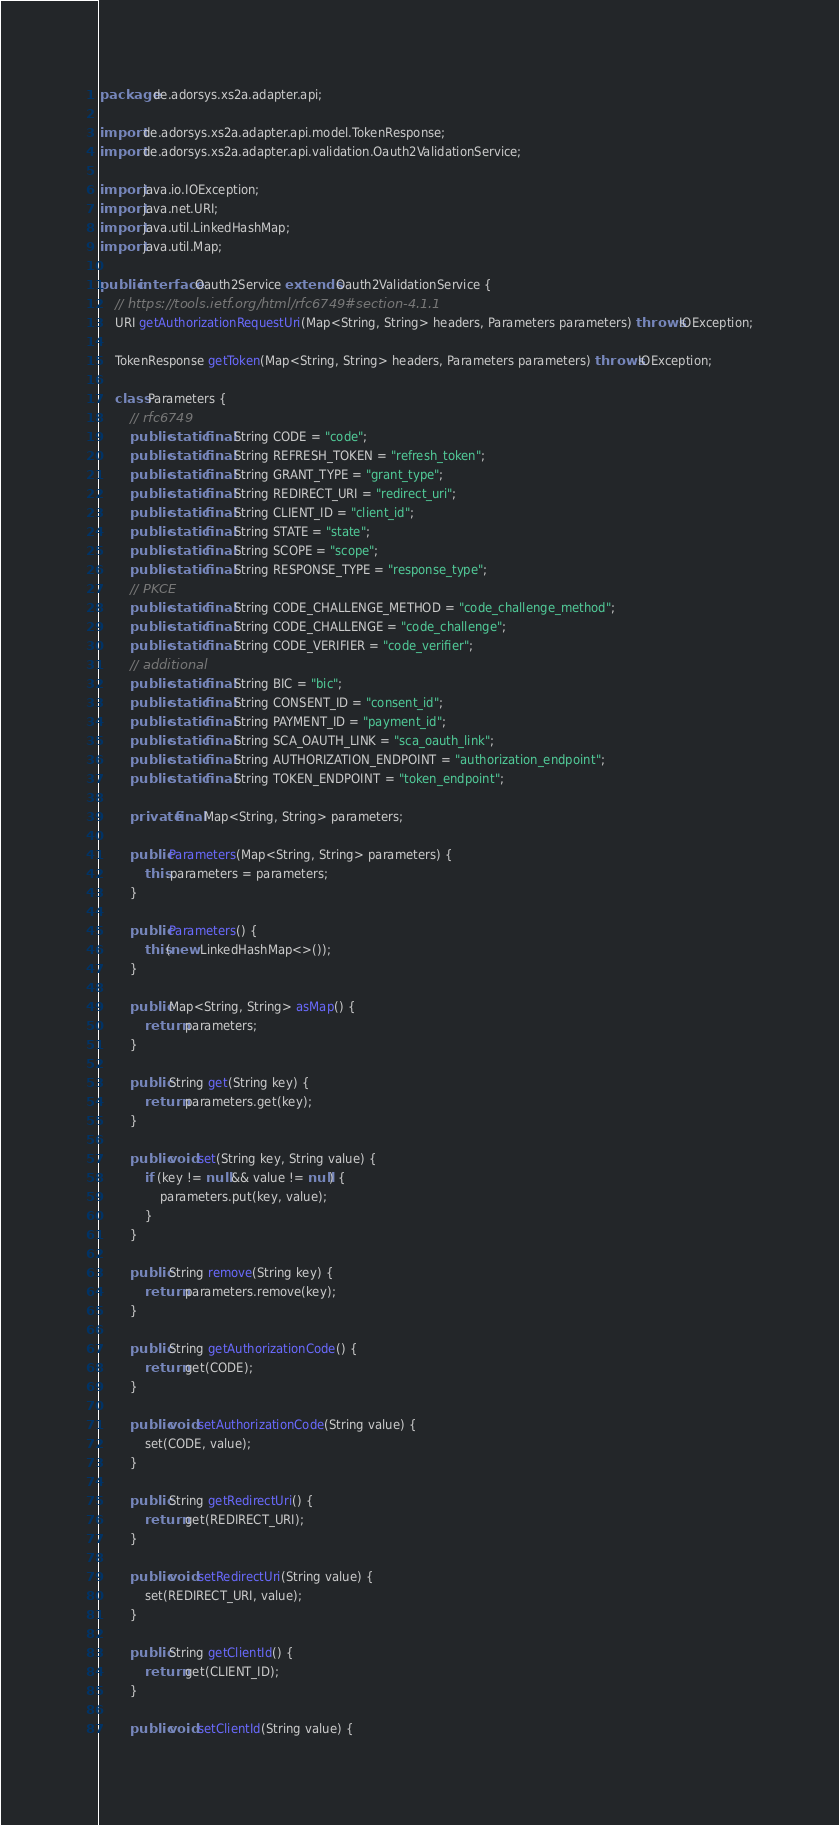Convert code to text. <code><loc_0><loc_0><loc_500><loc_500><_Java_>package de.adorsys.xs2a.adapter.api;

import de.adorsys.xs2a.adapter.api.model.TokenResponse;
import de.adorsys.xs2a.adapter.api.validation.Oauth2ValidationService;

import java.io.IOException;
import java.net.URI;
import java.util.LinkedHashMap;
import java.util.Map;

public interface Oauth2Service extends Oauth2ValidationService {
    // https://tools.ietf.org/html/rfc6749#section-4.1.1
    URI getAuthorizationRequestUri(Map<String, String> headers, Parameters parameters) throws IOException;

    TokenResponse getToken(Map<String, String> headers, Parameters parameters) throws IOException;

    class Parameters {
        // rfc6749
        public static final String CODE = "code";
        public static final String REFRESH_TOKEN = "refresh_token";
        public static final String GRANT_TYPE = "grant_type";
        public static final String REDIRECT_URI = "redirect_uri";
        public static final String CLIENT_ID = "client_id";
        public static final String STATE = "state";
        public static final String SCOPE = "scope";
        public static final String RESPONSE_TYPE = "response_type";
        // PKCE
        public static final String CODE_CHALLENGE_METHOD = "code_challenge_method";
        public static final String CODE_CHALLENGE = "code_challenge";
        public static final String CODE_VERIFIER = "code_verifier";
        // additional
        public static final String BIC = "bic";
        public static final String CONSENT_ID = "consent_id";
        public static final String PAYMENT_ID = "payment_id";
        public static final String SCA_OAUTH_LINK = "sca_oauth_link";
        public static final String AUTHORIZATION_ENDPOINT = "authorization_endpoint";
        public static final String TOKEN_ENDPOINT = "token_endpoint";

        private final Map<String, String> parameters;

        public Parameters(Map<String, String> parameters) {
            this.parameters = parameters;
        }

        public Parameters() {
            this(new LinkedHashMap<>());
        }

        public Map<String, String> asMap() {
            return parameters;
        }

        public String get(String key) {
            return parameters.get(key);
        }

        public void set(String key, String value) {
            if (key != null && value != null) {
                parameters.put(key, value);
            }
        }

        public String remove(String key) {
            return parameters.remove(key);
        }

        public String getAuthorizationCode() {
            return get(CODE);
        }

        public void setAuthorizationCode(String value) {
            set(CODE, value);
        }

        public String getRedirectUri() {
            return get(REDIRECT_URI);
        }

        public void setRedirectUri(String value) {
            set(REDIRECT_URI, value);
        }

        public String getClientId() {
            return get(CLIENT_ID);
        }

        public void setClientId(String value) {</code> 